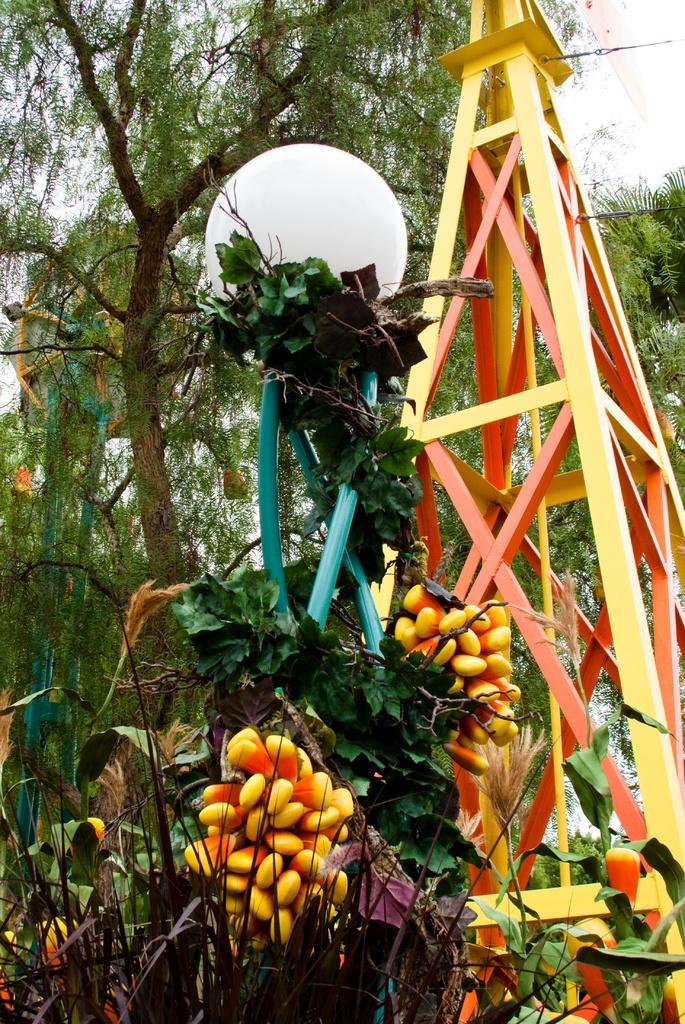What type of structure is present in the image? There is a metal structure in the image. What is located in front of the metal structure? There is a plastic tree with fruits in front of the metal structure. What is attached to the plastic tree? There is a lamp on the plastic tree. What can be seen behind the metal structure? There is a tree behind the metal structure. What type of knife is hanging from the lamp on the plastic tree? There is no knife present on the plastic tree or the lamp in the image. What smell can be detected from the fruits on the plastic tree? The image does not provide any information about the smell of the fruits, as it only shows a visual representation. 